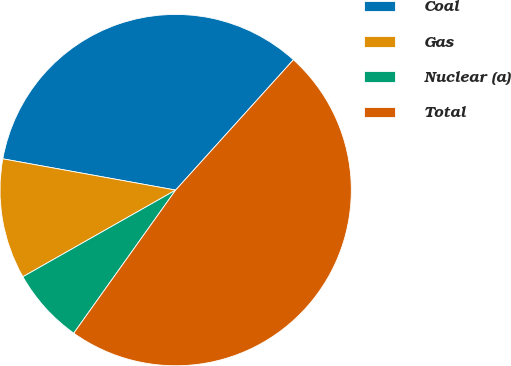<chart> <loc_0><loc_0><loc_500><loc_500><pie_chart><fcel>Coal<fcel>Gas<fcel>Nuclear (a)<fcel>Total<nl><fcel>33.85%<fcel>11.06%<fcel>6.94%<fcel>48.15%<nl></chart> 